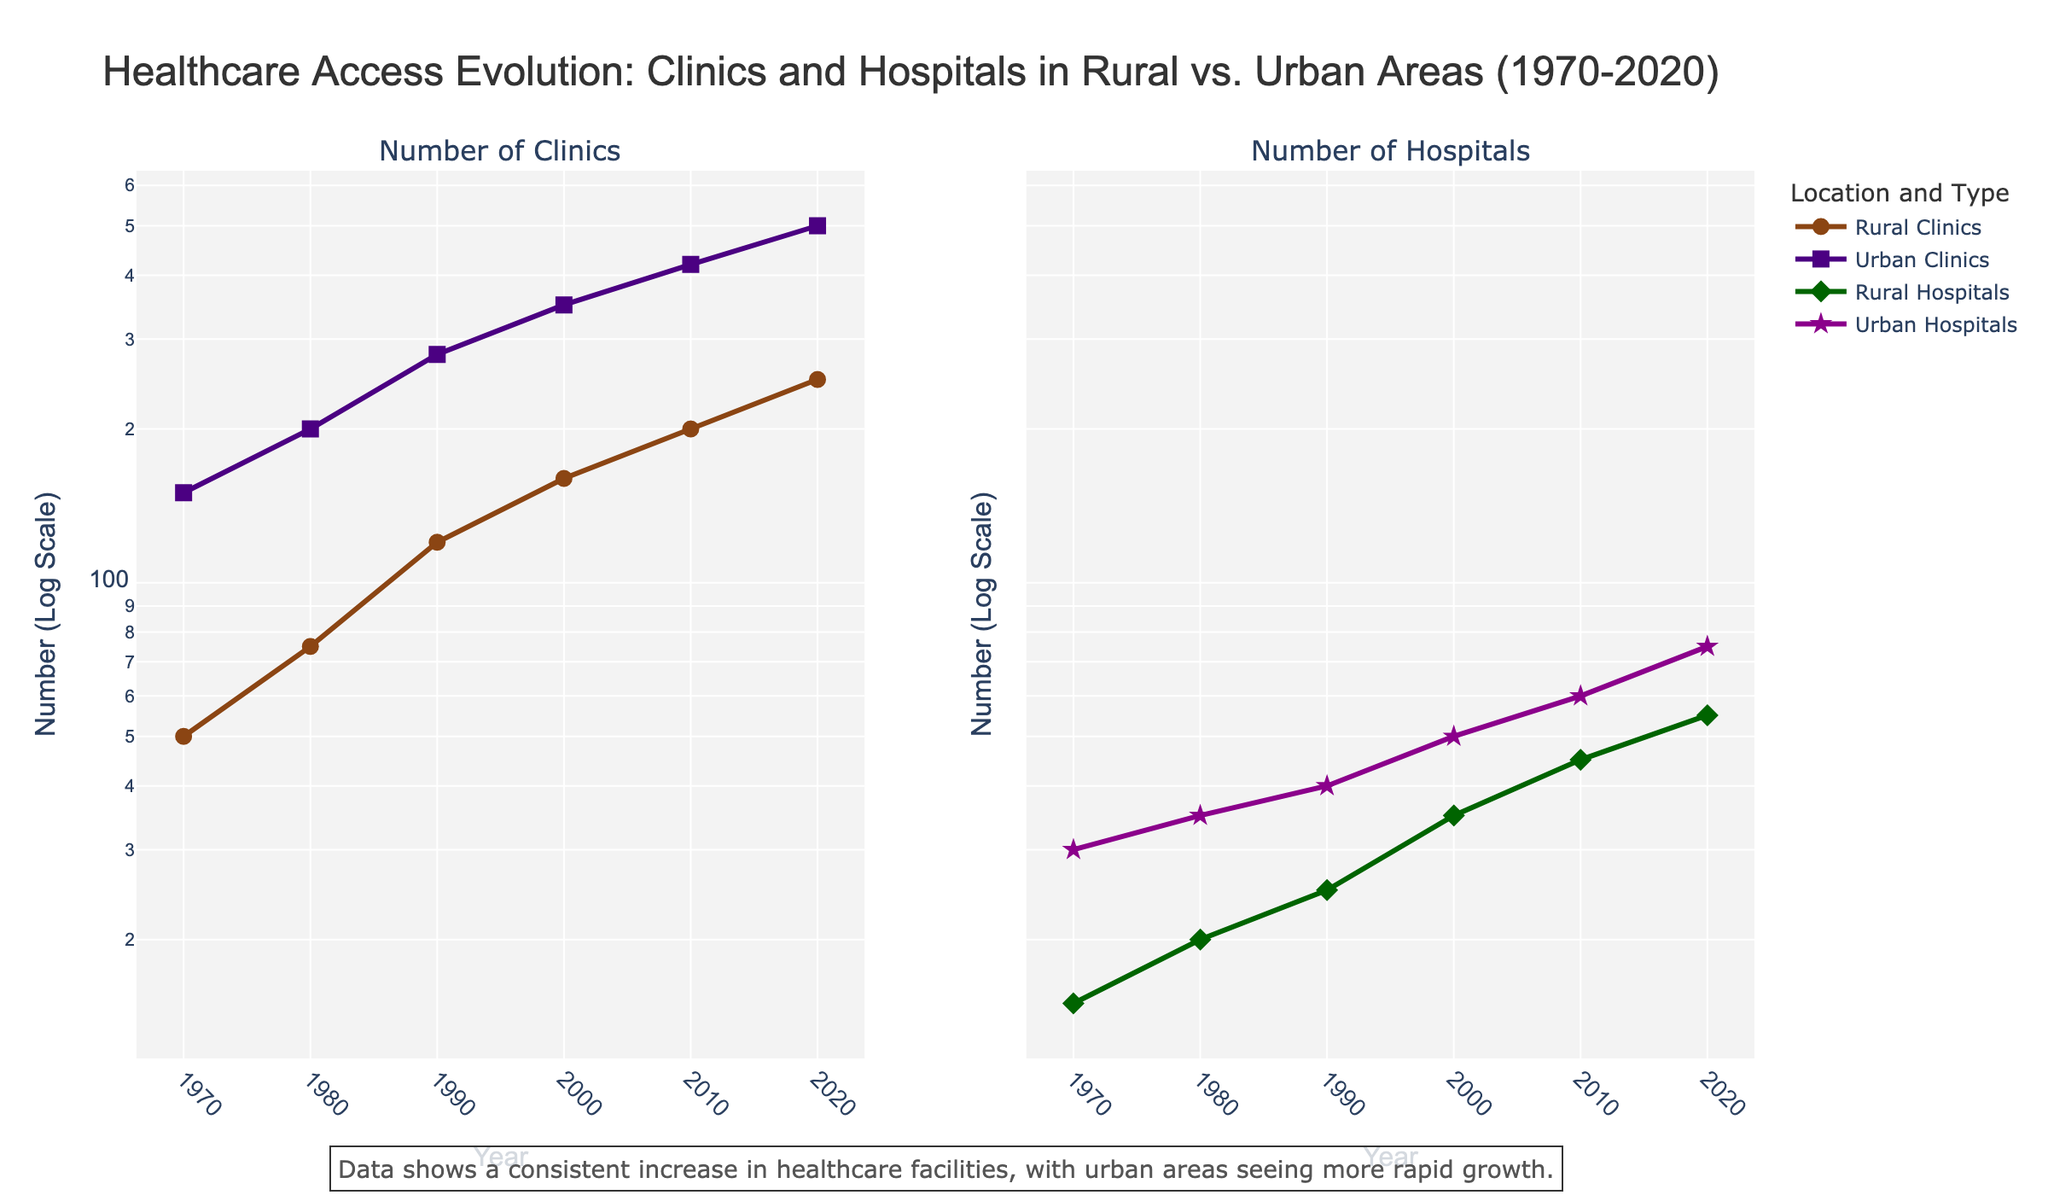What is the title of the figure? The title is usually displayed at the top center of the figure, providing a summary of what the figure represents.
Answer: Healthcare Access Evolution: Clinics and Hospitals in Rural vs. Urban Areas (1970-2020) What does the y-axis represent? The y-axis represents the measurement scale for the number of clinics and hospitals, and it uses a logarithmic scale to depict a wide range of values.
Answer: Number (Log Scale) How many data points are there for Rural Clinics? To determine the number of data points for Rural Clinics, count the markers on the "Number of Clinics" subplot associated with the rural data line. There are markers for each recorded year.
Answer: 6 Which location had a higher number of hospitals in the year 2000? Compare the points on the "Number of Hospitals" subplot for the year 2000 between Rural Hospitals and Urban Hospitals. Urban Hospitals are at around 50, and Rural Hospitals are at around 35.
Answer: Urban During which decade did Urban Clinics see the most significant increase in the number of clinics built? Examine the slope of the line representing Urban Clinics in each decade from 1970 to 2020, looking for the steepest increase, which indicates the most significant rise. The increase between 1990 and 2000 is the steepest.
Answer: 1990s How does the number of rural hospitals in 2010 compare to the number of urban hospitals in 1990? Check the "Number of Hospitals" subplot for the two specified values; rural hospitals in 2010 are around 45, which is greater than urban hospitals in 1990, which are around 40.
Answer: Greater than What trend do you observe in the number of clinics in rural areas from 1970 to 2020? Review the line plot for Rural Clinics on the left subplot and note the overall trend. The line shows a steady increase over time.
Answer: Steady increase How does the growth rate of urban hospitals between 2010 and 2020 compare to the growth rate of rural hospitals in the same period? Assess the slopes of the urban and rural hospital lines between 2010 and 2020 on the "Number of Hospitals" subplot. The urban hospitals line shows a stronger upward slope than the rural hospitals line, indicating a higher growth rate.
Answer: Urban hospitals grew faster What is the difference in the number of urban clinics between 1990 and 1980? Look at the values of urban clinics for 1990 and 1980 on the "Number of Clinics" subplot. The number in 1990 is 280, and in 1980, it's 200. Subtract the latter from the former. 280 - 200 = 80
Answer: 80 Determine the average number of rural clinics built in the years 1980, 1990, and 2000. Add the number of rural clinics for the years 1980 (75), 1990 (120), and 2000 (160). Divide the sum by 3: (75 + 120 + 160) / 3 = 355 / 3 = 118.33
Answer: 118.33 